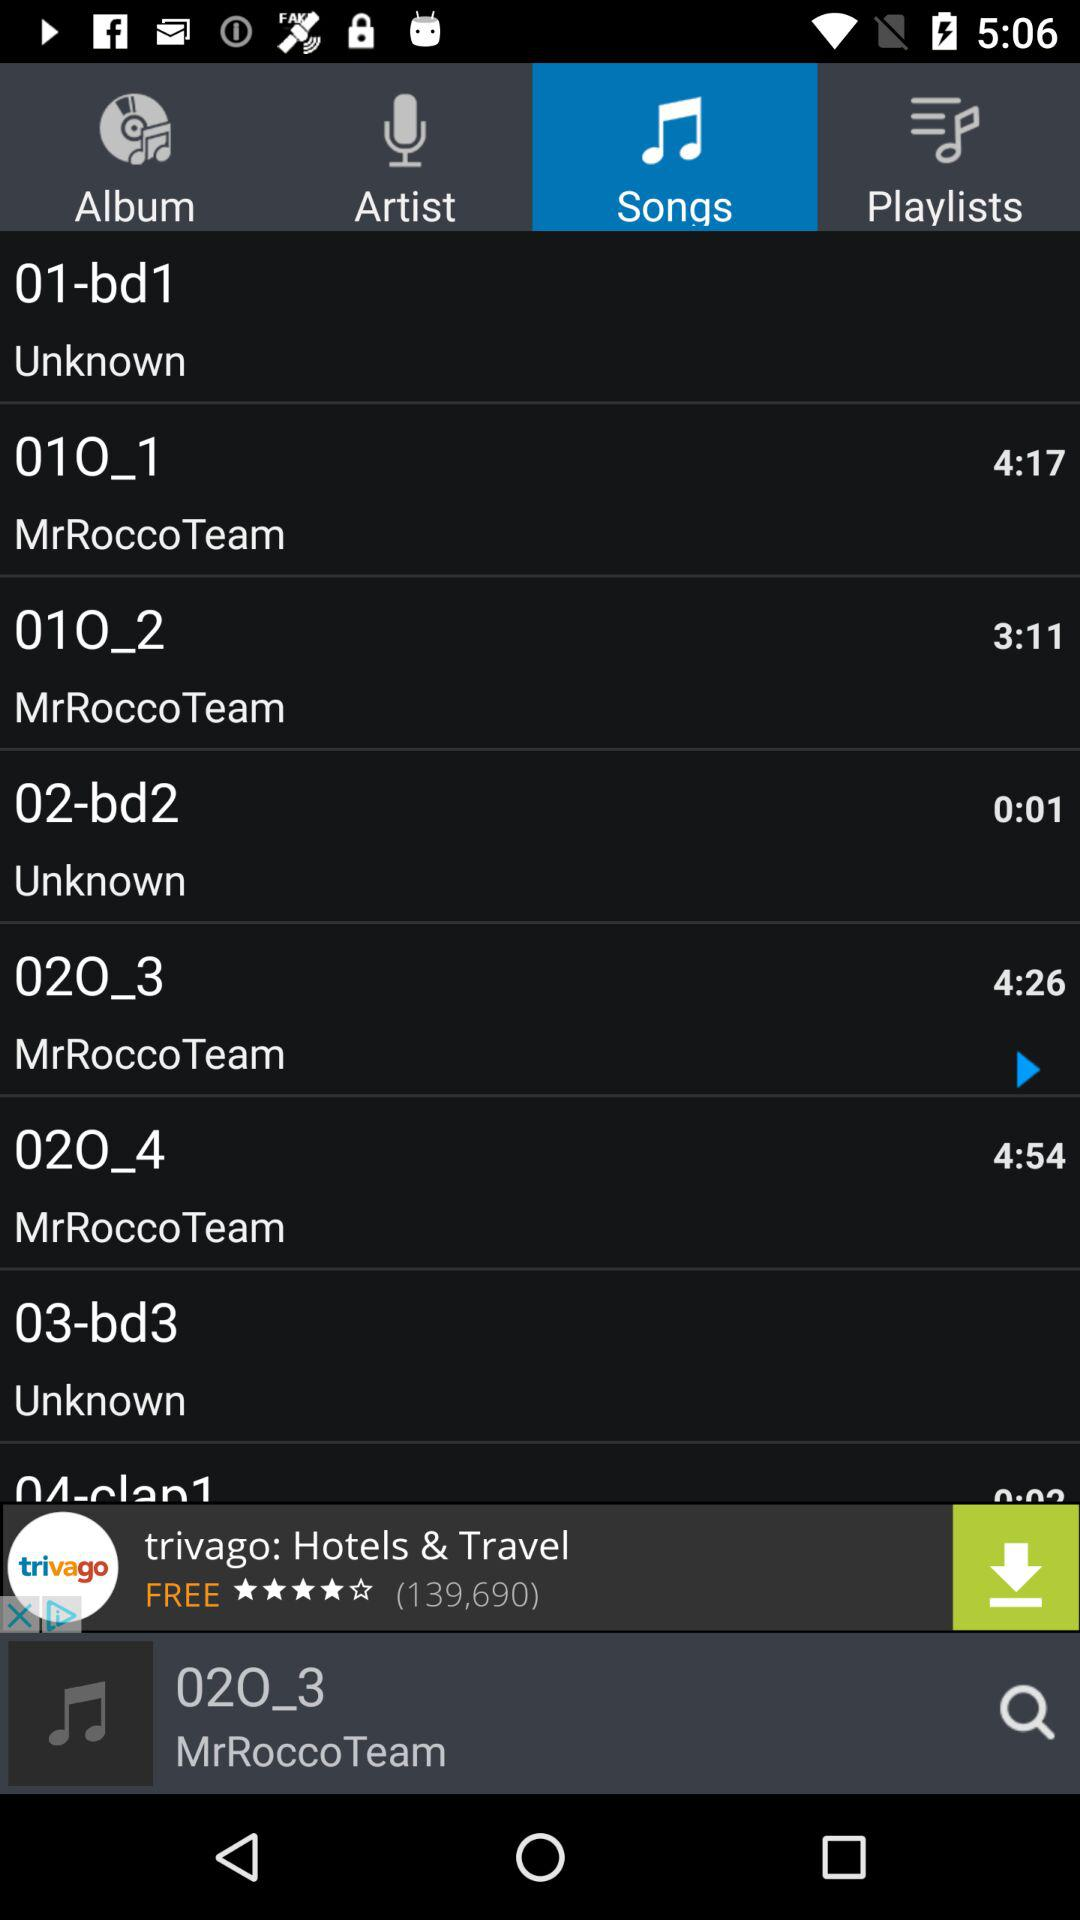Which song is currently playing? The song currently being played is "020_3". 